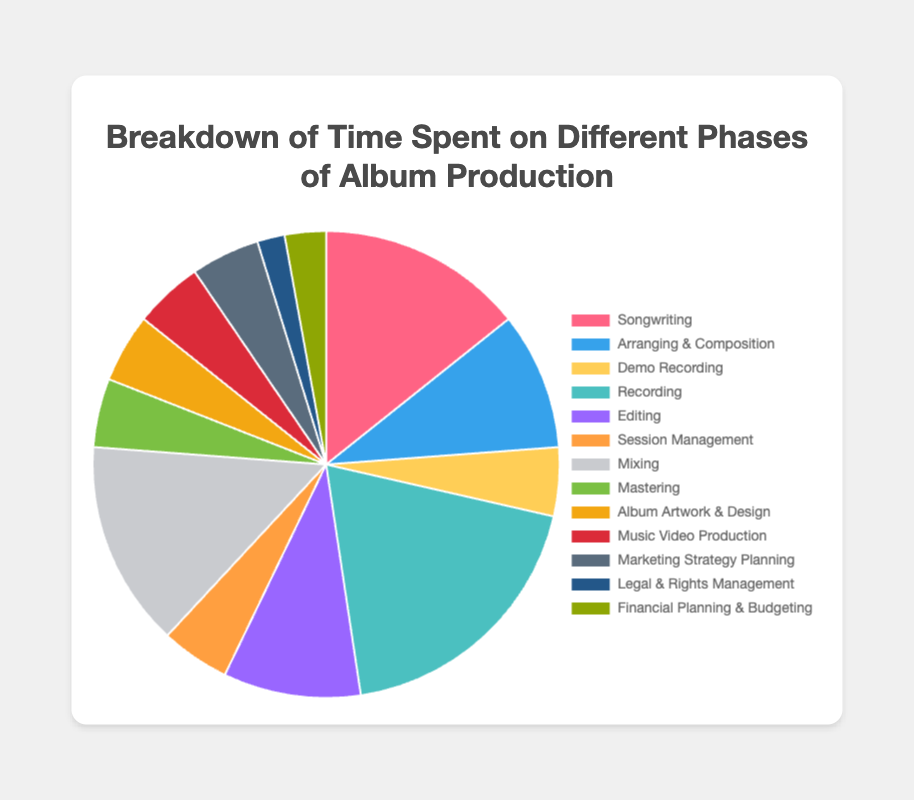Which activity takes the most time in the album production process? The pie chart shows that 'Recording' has the largest segment, indicating it takes up 20% of the total time.
Answer: Recording What is the total percentage of time spent on Pre-production activities? Add the percentages for 'Songwriting' (15%), 'Arranging & Composition' (10%), and 'Demo Recording' (5%): 15% + 10% + 5% = 30%.
Answer: 30% Which phase has the least time allocated, and what is the percentage? The 'Administrative' phase shows the smallest segments: 'Legal & Rights Management' (2%) and 'Financial Planning & Budgeting' (3%), adding up to 5%.
Answer: Administrative, 5% How does the time spent on 'Mixing' compare to 'Mastering'? 'Mixing' takes 15% of the time whereas 'Mastering' takes 5%. Compare them: 15% is greater than 5%.
Answer: Mixing takes 10% more What are the combined percentages for all activities under Production? Add the percentages for 'Recording' (20%), 'Editing' (10%), and 'Session Management' (5%): 20% + 10% + 5% = 35%.
Answer: 35% What is the percentage difference between 'Songwriting' and 'Arranging & Composition'? Subtract 'Arranging & Composition' percentage (10%) from 'Songwriting' percentage (15%): 15% - 10% = 5%.
Answer: 5% What is the median value of time spent percentages across all activities? List percentages in order: 2%, 3%, 5%, 5%, 5%, 5%, 10%, 10%, 15%, 15%, 20%. Median is the middle value in this list, which is 5%.
Answer: 5% How much time is spent on Marketing Strategy Planning compared to Album Artwork & Design? Both activities under 'Creative & Marketing' take 5% each.
Answer: Equal Which activity has the smallest segment and what color represents it? 'Legal & Rights Management' has the smallest segment at 2%. In the chart, this is represented by the blue color.
Answer: Legal & Rights Management, blue 